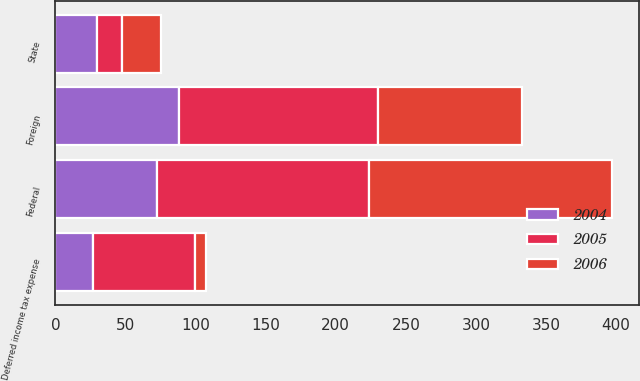Convert chart to OTSL. <chart><loc_0><loc_0><loc_500><loc_500><stacked_bar_chart><ecel><fcel>Federal<fcel>State<fcel>Foreign<fcel>Deferred income tax expense<nl><fcel>2004<fcel>72.7<fcel>29.8<fcel>88<fcel>27.1<nl><fcel>2006<fcel>173<fcel>27.3<fcel>102.8<fcel>7.9<nl><fcel>2005<fcel>151<fcel>17.9<fcel>141.9<fcel>72.7<nl></chart> 